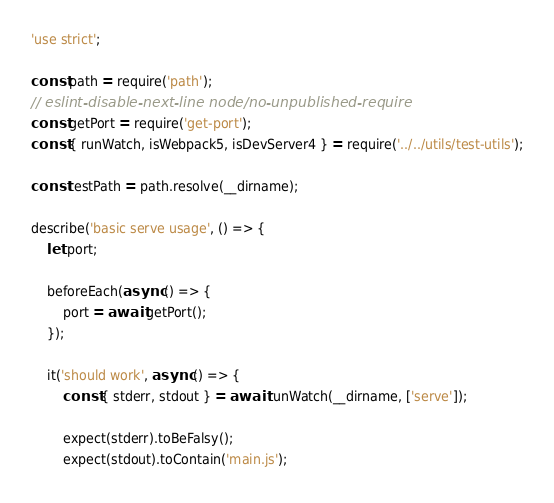<code> <loc_0><loc_0><loc_500><loc_500><_JavaScript_>'use strict';

const path = require('path');
// eslint-disable-next-line node/no-unpublished-require
const getPort = require('get-port');
const { runWatch, isWebpack5, isDevServer4 } = require('../../utils/test-utils');

const testPath = path.resolve(__dirname);

describe('basic serve usage', () => {
    let port;

    beforeEach(async () => {
        port = await getPort();
    });

    it('should work', async () => {
        const { stderr, stdout } = await runWatch(__dirname, ['serve']);

        expect(stderr).toBeFalsy();
        expect(stdout).toContain('main.js');</code> 